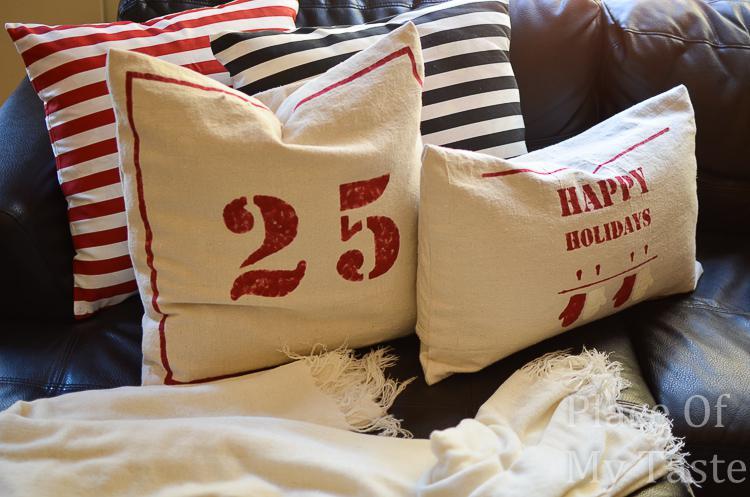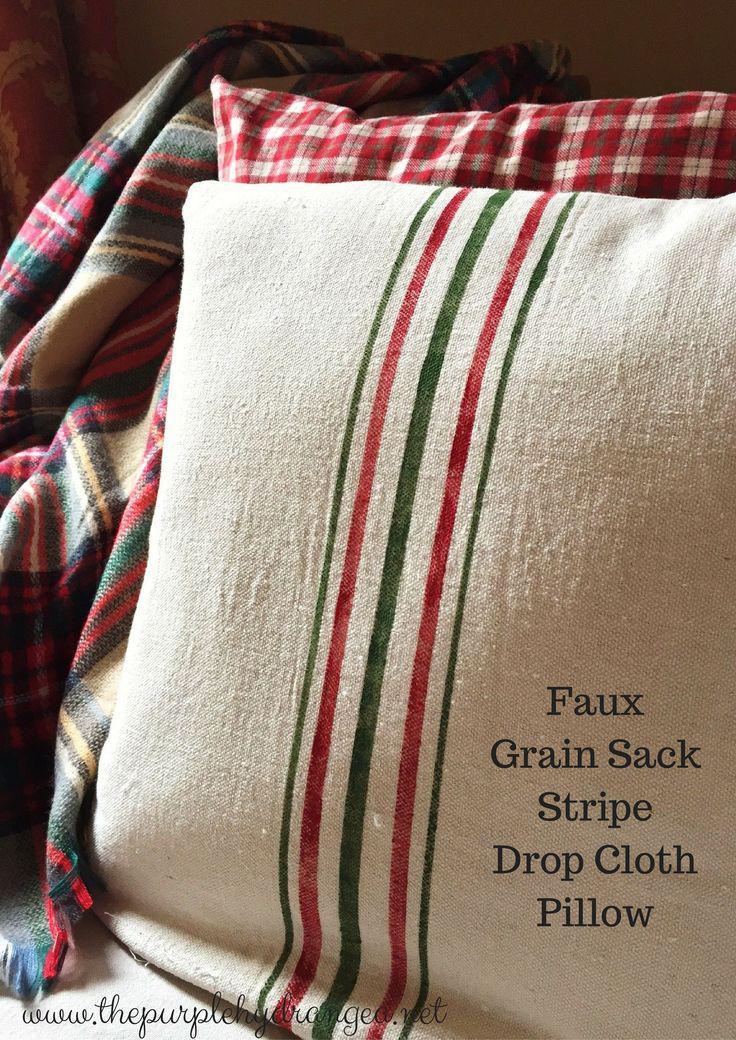The first image is the image on the left, the second image is the image on the right. Evaluate the accuracy of this statement regarding the images: "One image has a pillow with vertical strips going down the center.". Is it true? Answer yes or no. Yes. 